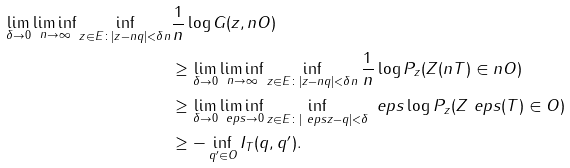<formula> <loc_0><loc_0><loc_500><loc_500>\lim _ { \delta \to 0 } \liminf _ { n \to \infty } \inf _ { z \in E \colon | z - n q | < \delta n } & \frac { 1 } { n } \log G ( z , n O ) \\ & \geq \lim _ { \delta \to 0 } \liminf _ { n \to \infty } \inf _ { z \in E \colon | z - n q | < \delta n } \frac { 1 } { n } \log P _ { z } ( Z ( n T ) \in n O ) \\ & \geq \lim _ { \delta \to 0 } \liminf _ { \ e p s \to 0 } \inf _ { z \in E \colon | \ e p s z - q | < \delta } \ e p s \log P _ { z } ( Z ^ { \ } e p s ( T ) \in O ) \\ & \geq - \inf _ { q ^ { \prime } \in O } I _ { T } ( q , q ^ { \prime } ) .</formula> 